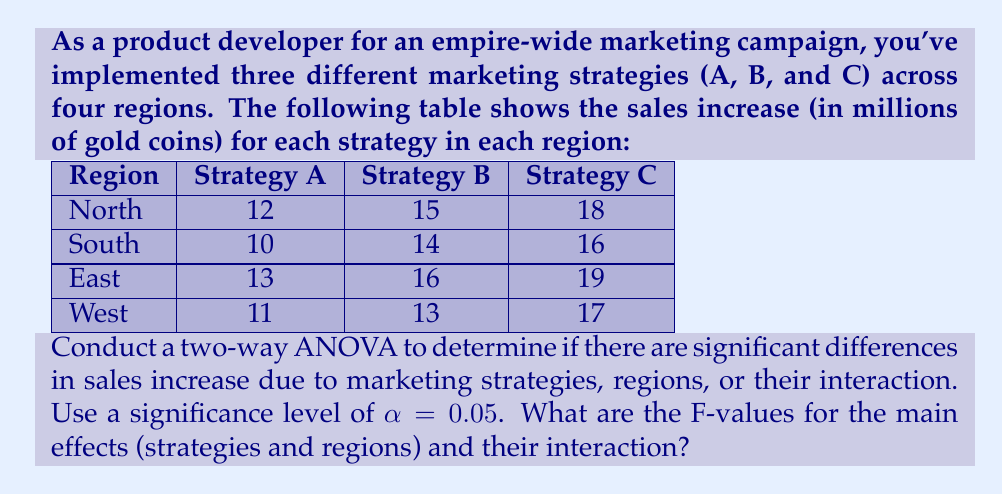Provide a solution to this math problem. To conduct a two-way ANOVA, we need to calculate the following:

1. Sum of Squares (SS) for strategies, regions, interaction, and error
2. Degrees of freedom (df) for each source of variation
3. Mean Square (MS) for each source of variation
4. F-values for strategies, regions, and interaction

Step 1: Calculate the grand mean and total sum of squares

Grand mean: $\bar{X} = \frac{\sum_{i=1}^{4}\sum_{j=1}^{3} X_{ij}}{N} = \frac{174}{12} = 14.5$

Total SS: $SS_{total} = \sum_{i=1}^{4}\sum_{j=1}^{3} (X_{ij} - \bar{X})^2 = 122$

Step 2: Calculate SS for strategies

$SS_{strategies} = 3 \sum_{j=1}^{3} (\bar{X}_j - \bar{X})^2 = 84$

Step 3: Calculate SS for regions

$SS_{regions} = 3 \sum_{i=1}^{4} (\bar{X}_i - \bar{X})^2 = 10$

Step 4: Calculate SS for interaction

$SS_{interaction} = \sum_{i=1}^{4}\sum_{j=1}^{3} (X_{ij} - \bar{X}_i - \bar{X}_j + \bar{X})^2 = 2$

Step 5: Calculate SS for error

$SS_{error} = SS_{total} - SS_{strategies} - SS_{regions} - SS_{interaction} = 26$

Step 6: Calculate degrees of freedom (df)

$df_{strategies} = 3 - 1 = 2$
$df_{regions} = 4 - 1 = 3$
$df_{interaction} = (3-1)(4-1) = 6$
$df_{error} = 12 - (2 + 3 + 6) = 1$

Step 7: Calculate Mean Square (MS)

$MS_{strategies} = \frac{SS_{strategies}}{df_{strategies}} = 42$
$MS_{regions} = \frac{SS_{regions}}{df_{regions}} = 3.33$
$MS_{interaction} = \frac{SS_{interaction}}{df_{interaction}} = 0.33$
$MS_{error} = \frac{SS_{error}}{df_{error}} = 26$

Step 8: Calculate F-values

$F_{strategies} = \frac{MS_{strategies}}{MS_{error}} = 1.62$
$F_{regions} = \frac{MS_{regions}}{MS_{error}} = 0.13$
$F_{interaction} = \frac{MS_{interaction}}{MS_{error}} = 0.013$
Answer: The F-values for the main effects and interaction are:

Strategies: $F_{strategies} = 1.62$
Regions: $F_{regions} = 0.13$
Interaction: $F_{interaction} = 0.013$ 